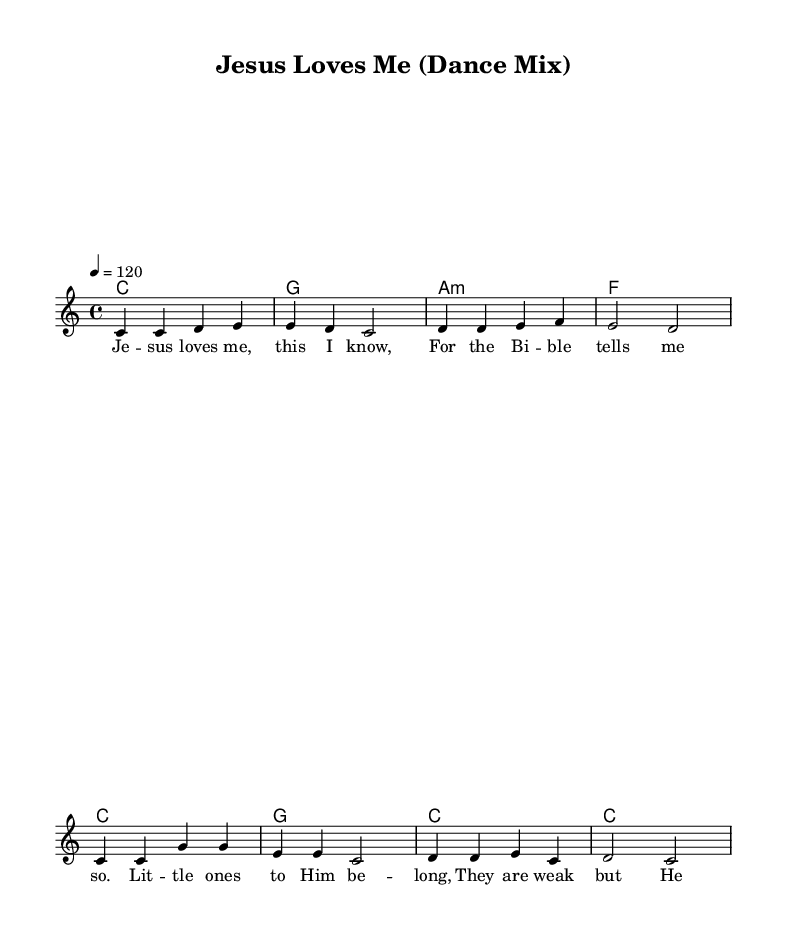What is the key signature of this music? The key signature is indicated at the beginning of the piece and shows that there are no sharps or flats, which corresponds to C major.
Answer: C major What is the time signature of this music? The time signature is found at the beginning of the score, represented by the 4 over 4, indicating there are four beats per measure.
Answer: 4/4 What is the tempo marking of this music? The tempo marking is noted as "4 = 120," which tells us that there are 120 quarter note beats in a minute.
Answer: 120 How many measures are in the melody section? By counting the vertical bar lines in the melody, which denote the end of each measure, we find there are eight measures total.
Answer: 8 Which chord comes after the second measure of the melody? The second measure’s corresponding chord is identified in the harmony section, which shows that the chord is G major.
Answer: G What is the lyrical theme of this song? The lyrics express the love of Jesus and how He embraces children, which is a common theme in Christian music.
Answer: Jesus loves children What makes this song dance-friendly? The rhythm, indicated by a steady tempo and lively melody, makes it suitable for dancing, as it encourages movement and enjoyment.
Answer: Dance-friendly rhythm 